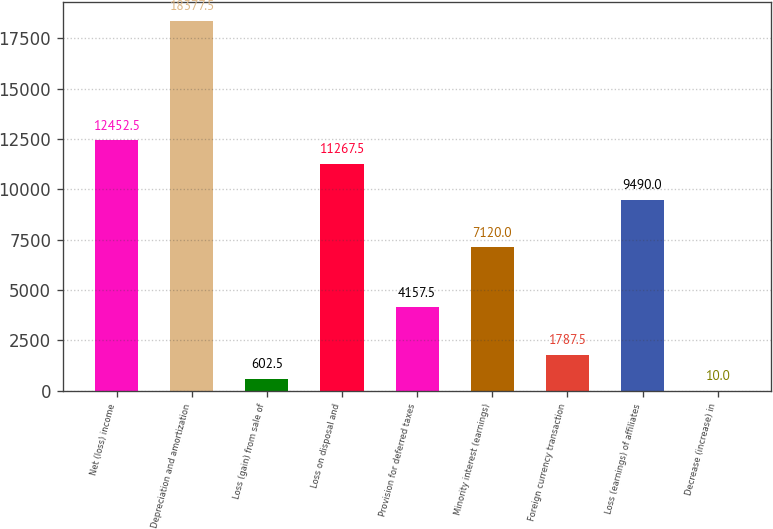Convert chart. <chart><loc_0><loc_0><loc_500><loc_500><bar_chart><fcel>Net (loss) income<fcel>Depreciation and amortization<fcel>Loss (gain) from sale of<fcel>Loss on disposal and<fcel>Provision for deferred taxes<fcel>Minority interest (earnings)<fcel>Foreign currency transaction<fcel>Loss (earnings) of affiliates<fcel>Decrease (increase) in<nl><fcel>12452.5<fcel>18377.5<fcel>602.5<fcel>11267.5<fcel>4157.5<fcel>7120<fcel>1787.5<fcel>9490<fcel>10<nl></chart> 